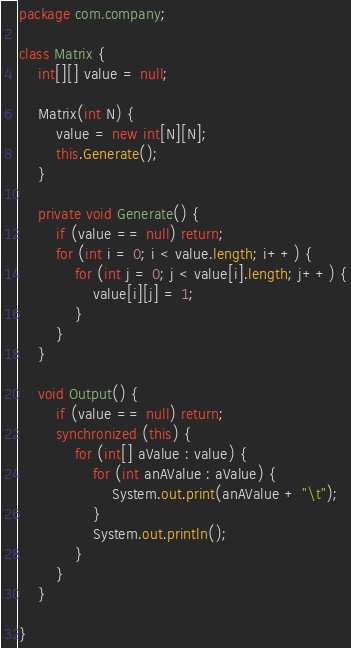<code> <loc_0><loc_0><loc_500><loc_500><_Java_>package com.company;

class Matrix {
    int[][] value = null;

    Matrix(int N) {
        value = new int[N][N];
        this.Generate();
    }

    private void Generate() {
        if (value == null) return;
        for (int i = 0; i < value.length; i++) {
            for (int j = 0; j < value[i].length; j++) {
                value[i][j] = 1;
            }
        }
    }

    void Output() {
        if (value == null) return;
        synchronized (this) {
            for (int[] aValue : value) {
                for (int anAValue : aValue) {
                    System.out.print(anAValue + "\t");
                }
                System.out.println();
            }
        }
    }

}
</code> 